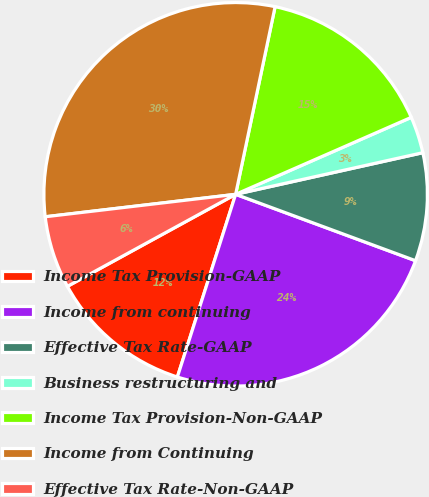Convert chart to OTSL. <chart><loc_0><loc_0><loc_500><loc_500><pie_chart><fcel>Income Tax Provision-GAAP<fcel>Income from continuing<fcel>Effective Tax Rate-GAAP<fcel>Business restructuring and<fcel>Income Tax Provision-Non-GAAP<fcel>Income from Continuing<fcel>Effective Tax Rate-Non-GAAP<nl><fcel>12.12%<fcel>24.29%<fcel>9.11%<fcel>3.09%<fcel>15.13%<fcel>30.17%<fcel>6.1%<nl></chart> 